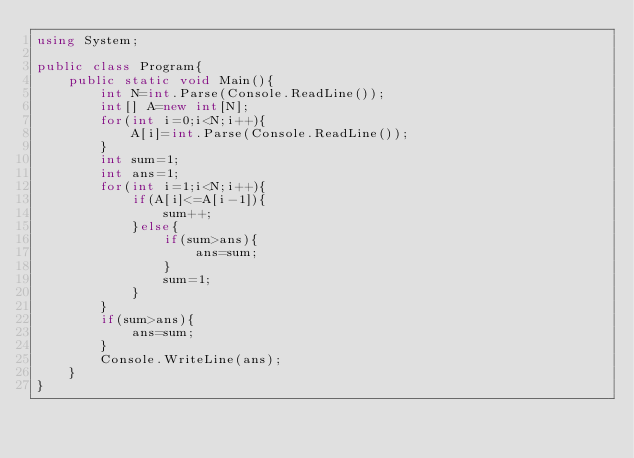Convert code to text. <code><loc_0><loc_0><loc_500><loc_500><_C#_>using System;

public class Program{
    public static void Main(){
        int N=int.Parse(Console.ReadLine());
        int[] A=new int[N];
        for(int i=0;i<N;i++){
            A[i]=int.Parse(Console.ReadLine());
        }
        int sum=1;
        int ans=1;
        for(int i=1;i<N;i++){
            if(A[i]<=A[i-1]){
                sum++;
            }else{
                if(sum>ans){
                    ans=sum;
                }
                sum=1;
            }
        }
        if(sum>ans){
            ans=sum;
        }
        Console.WriteLine(ans);
    }
}
</code> 